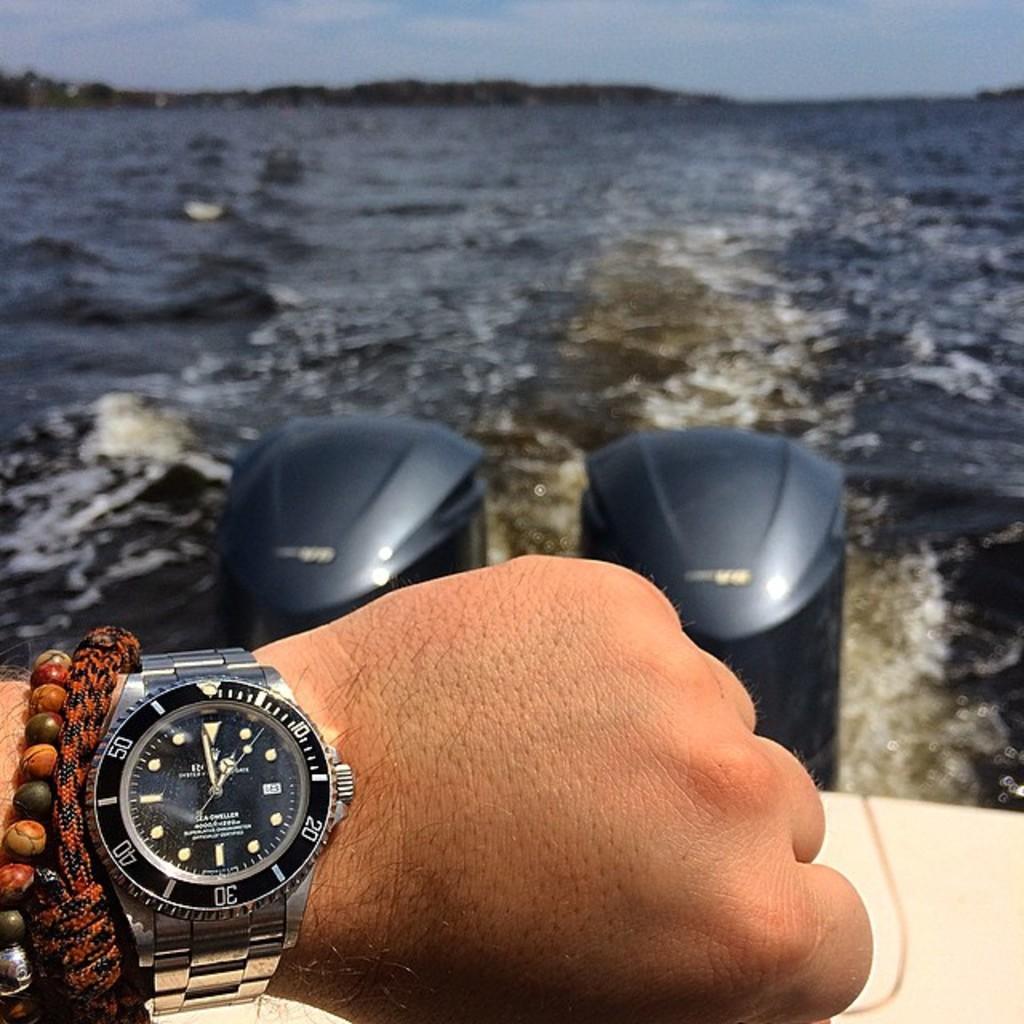What's the largest number on the edge of the watch?
Your response must be concise. 50. What time is it?
Make the answer very short. 12:59. 